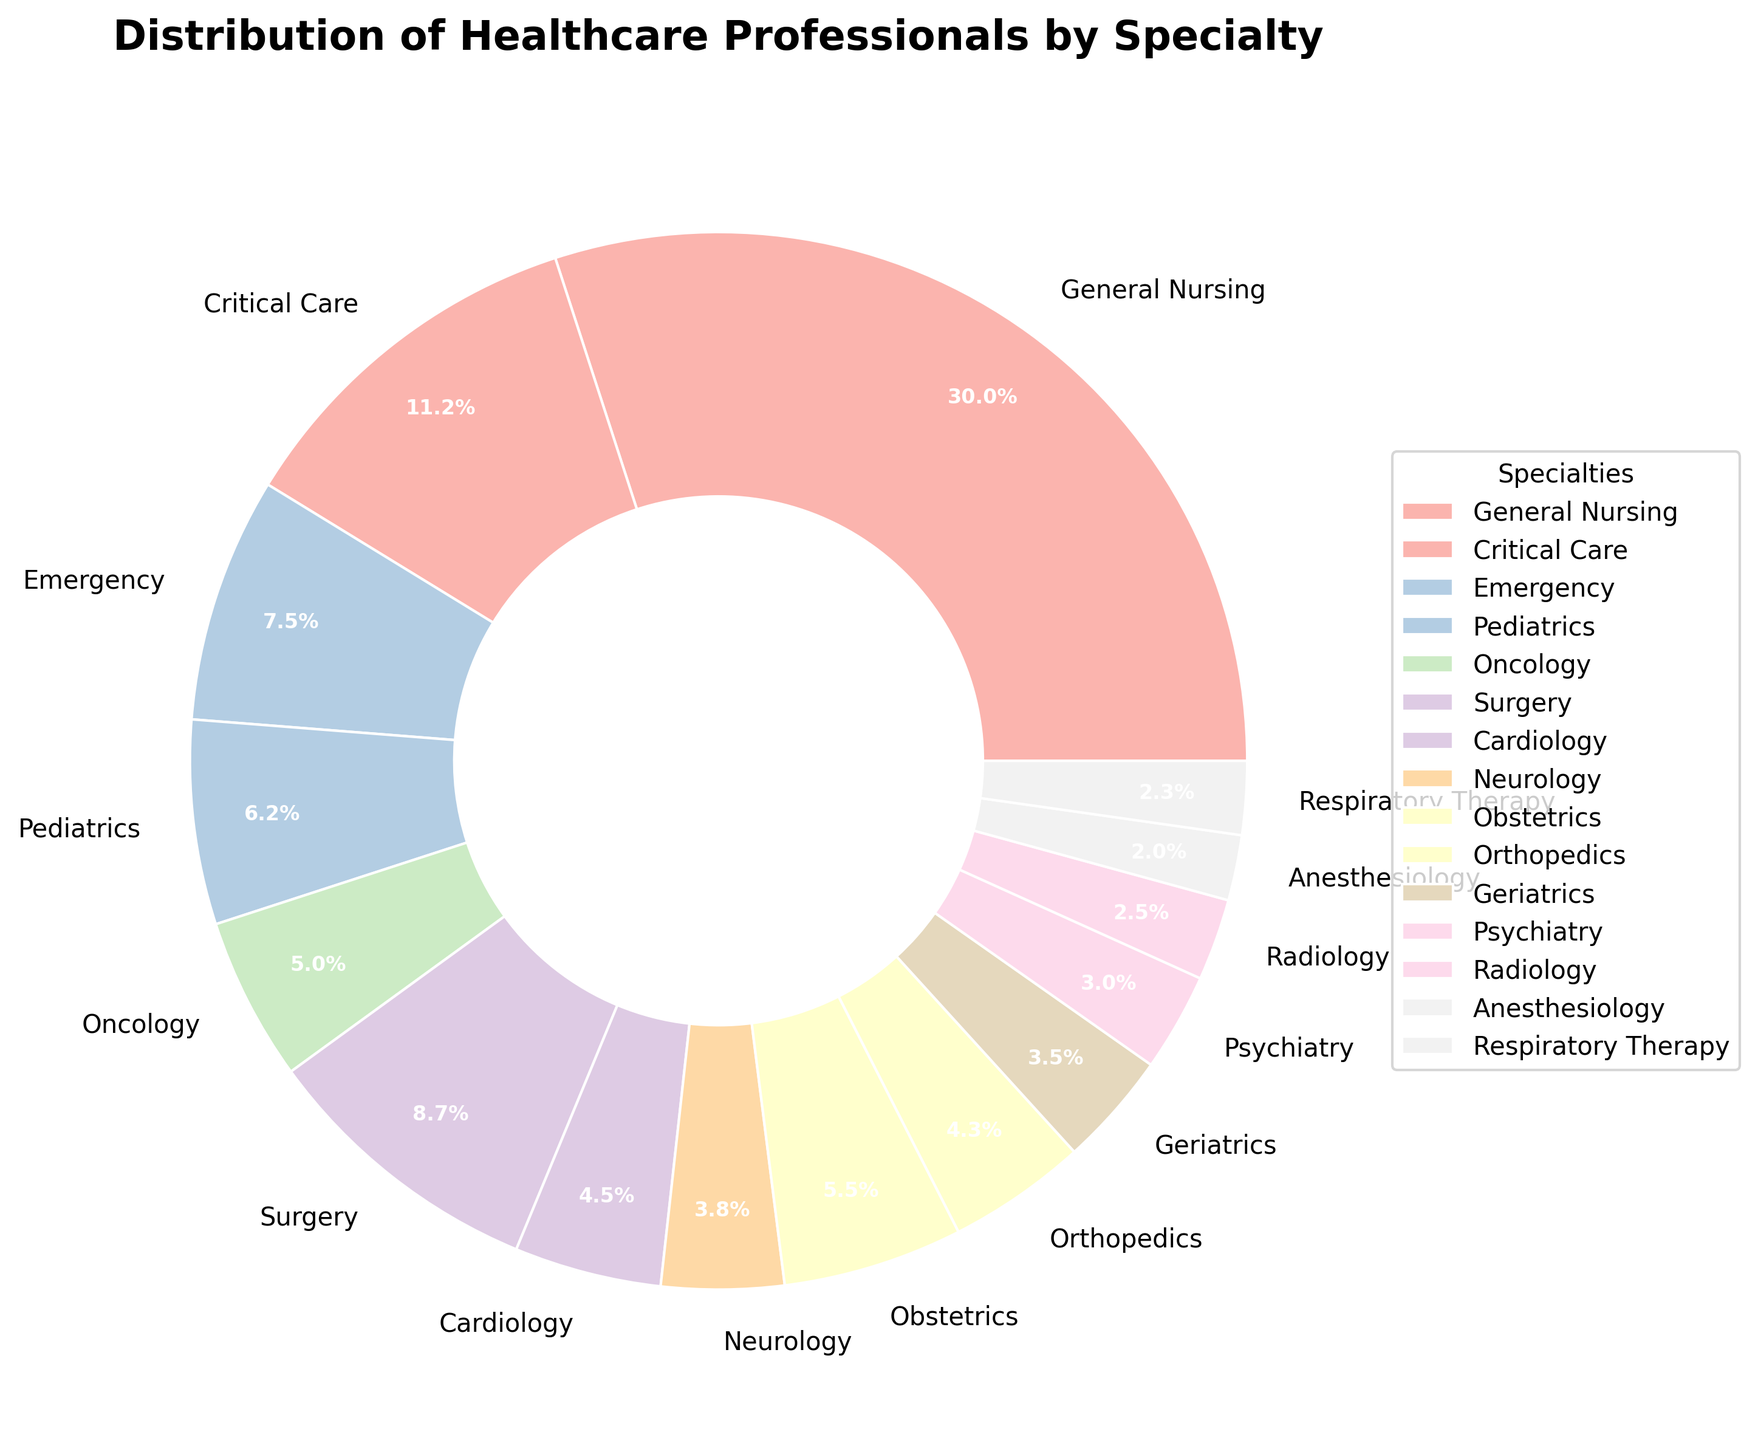What is the percentage of professionals in General Nursing? Locate the "General Nursing" segment and read the percentage value displayed inside the pie slice.
Answer: 38.5% How many more professionals are there in General Nursing than in Surgery? Identify the numbers of professionals in General Nursing (120) and Surgery (35), then calculate the difference (120 - 35).
Answer: 85 Which specialty has the fewest professionals and what percentage do they represent? Locate the smallest pie slice and read the label to identify the specialty (Anesthesiology), then find the percentage inside the slice.
Answer: Anesthesiology, 2.6% What is the combined percentage of professionals in Critical Care and Emergency? Identify the percentages for Critical Care (14.4%) and Emergency (9.6%), then add them together (14.4% + 9.6%).
Answer: 24% Are there more professionals in Pediatrics or Obstetrics, and by how many? Locate the slices for Pediatrics (25 professionals) and Obstetrics (22 professionals), then subtract the smaller number from the larger (25 - 22).
Answer: Pediatrics, by 3 What is the visual color associated with Psychiatry in the pie chart? Refer to the legend and match it with the pie slice labeled "Psychiatry" to determine the color used.
Answer: Light pink What's the total percentage of professionals in Neurology and Radiology, and are they more than Geriatrics combined? Calculate the total percentage of Neurology (4.8%) and Radiology (3.2%) (4.8% + 3.2% = 8%), then compare it with Geriatrics (4.5%).
Answer: 8%, Yes Which specialty has the closest number of professionals to Cardiology, and what is the difference in their counts? Identify the number of professionals in Cardiology (18) and find a specialty with a similar number (Orthopedics, 17), then calculate the difference (18 - 17).
Answer: Orthopedics, 1 What is the average number of professionals in Oncology, Surgery, and Geriatrics combined? Sum the professionals in these specialties (20 + 35 + 14 = 69) and divide by the number of specialties (3), (69 / 3).
Answer: 23 How does the size of the Psychiatry segment compare with that of Anesthesiology in the pie chart? Locate both Psychiatry (12 professionals, 3.8%) and Anesthesiology (8 professionals, 2.6%) slices, and compare their sizes visually.
Answer: Larger 